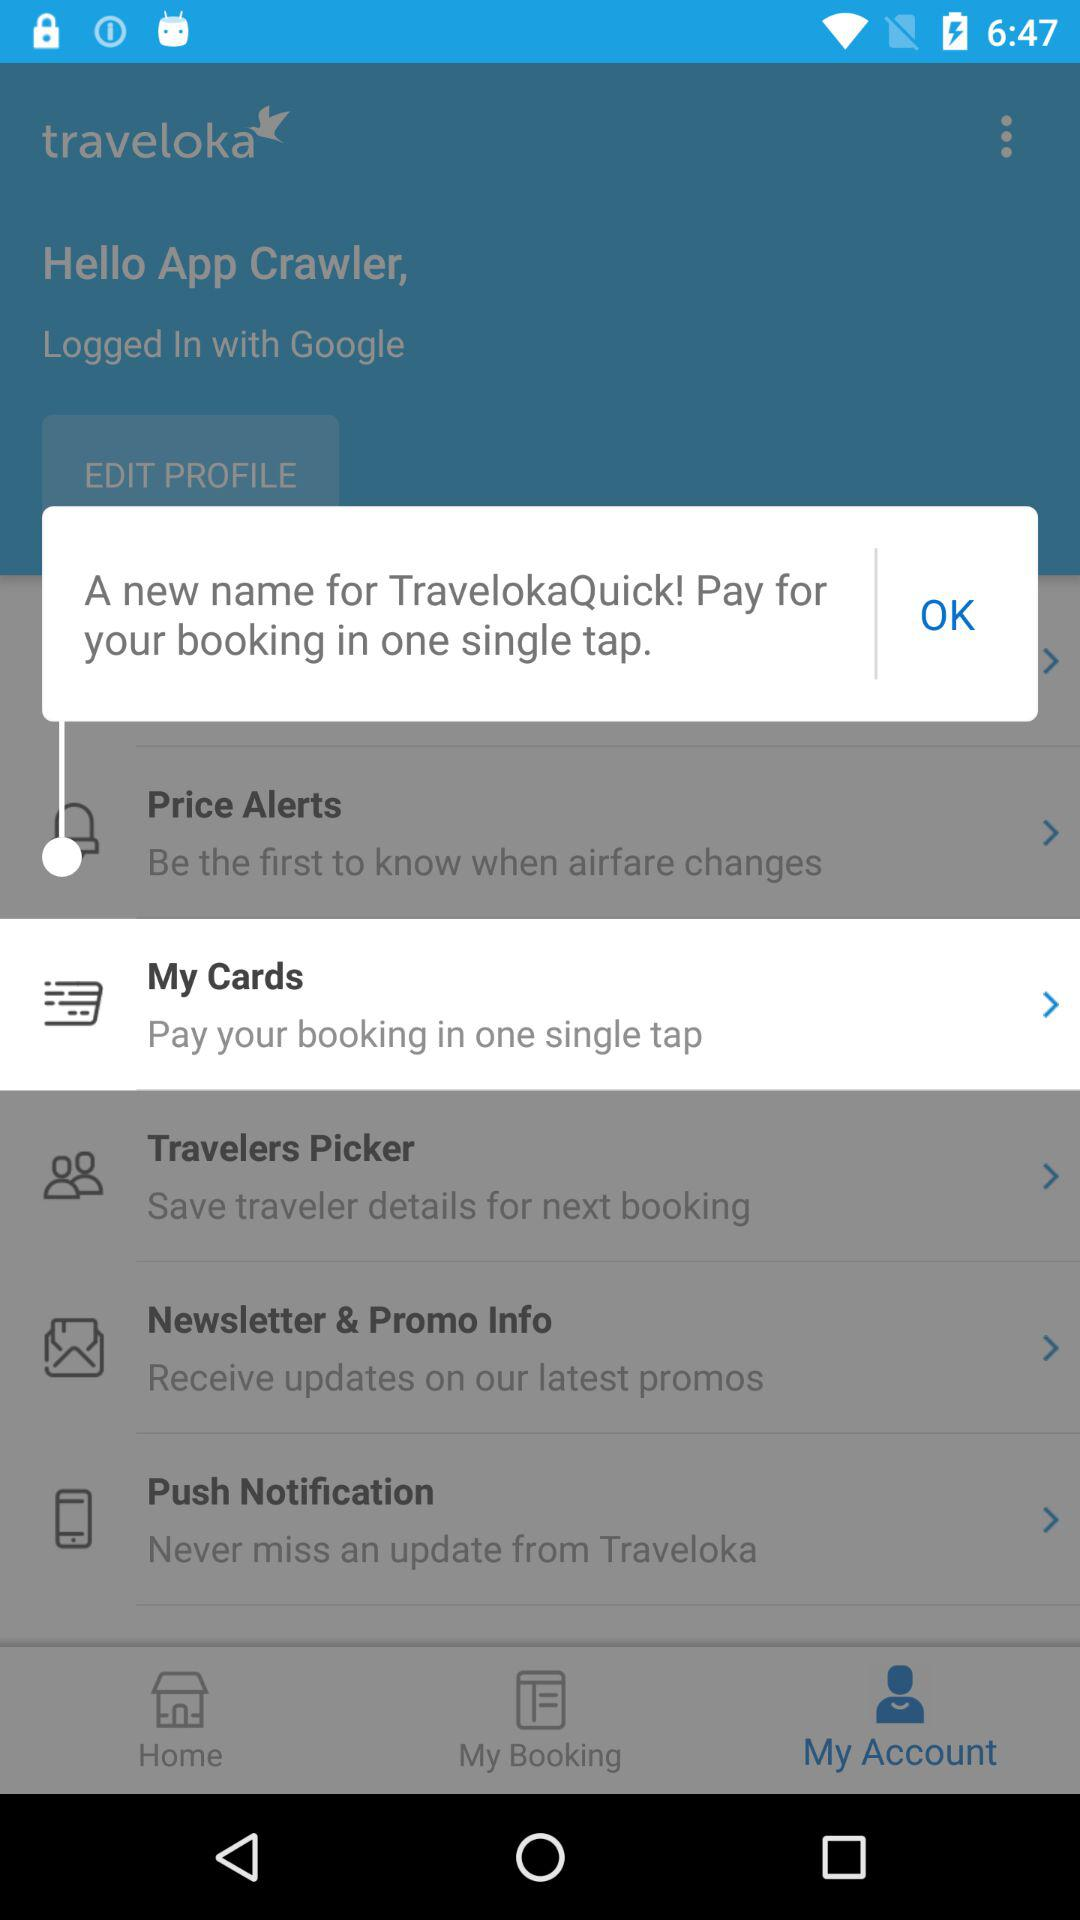Which tab is open? The opened tab is "My Account". 